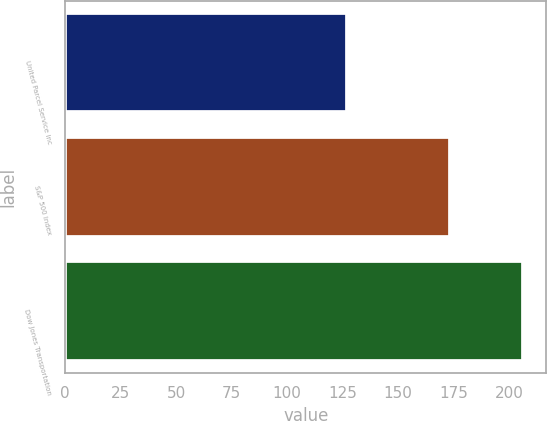Convert chart. <chart><loc_0><loc_0><loc_500><loc_500><bar_chart><fcel>United Parcel Service Inc<fcel>S&P 500 Index<fcel>Dow Jones Transportation<nl><fcel>127.08<fcel>173.33<fcel>206.46<nl></chart> 